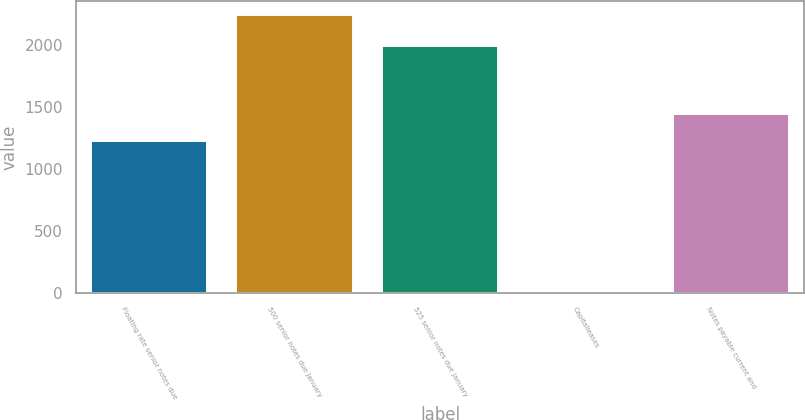Convert chart to OTSL. <chart><loc_0><loc_0><loc_500><loc_500><bar_chart><fcel>Floating rate senior notes due<fcel>500 senior notes due January<fcel>525 senior notes due January<fcel>Capitalleases<fcel>Notes payable current and<nl><fcel>1224.1<fcel>2244<fcel>1991<fcel>3<fcel>1448.2<nl></chart> 